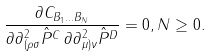<formula> <loc_0><loc_0><loc_500><loc_500>\frac { \partial C _ { B _ { 1 } \dots B _ { N } } } { \partial \partial ^ { 2 } _ { ( \rho \sigma } \hat { P } ^ { C } \, \partial \partial ^ { 2 } _ { \mu ) \nu } \hat { P } ^ { D } } = 0 , N \geq 0 .</formula> 